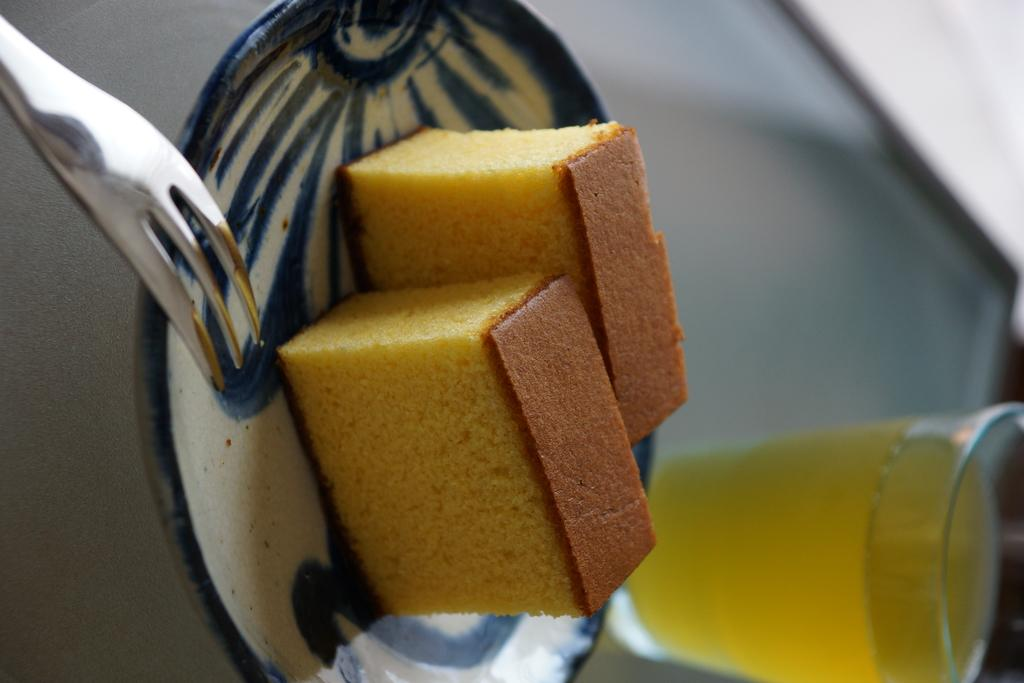What is on the plate in the image? There are two cake slices on a plate in the image. What utensil can be seen in the image? There is a fork in the image. What is in the glass in the image? There is a liquid in the glass in the image. Can you describe the background of the image? The background of the image is blurred. Where is the receipt for the cake in the image? There is no receipt present in the image. What type of playground equipment can be seen in the image? There is no playground equipment present in the image. 